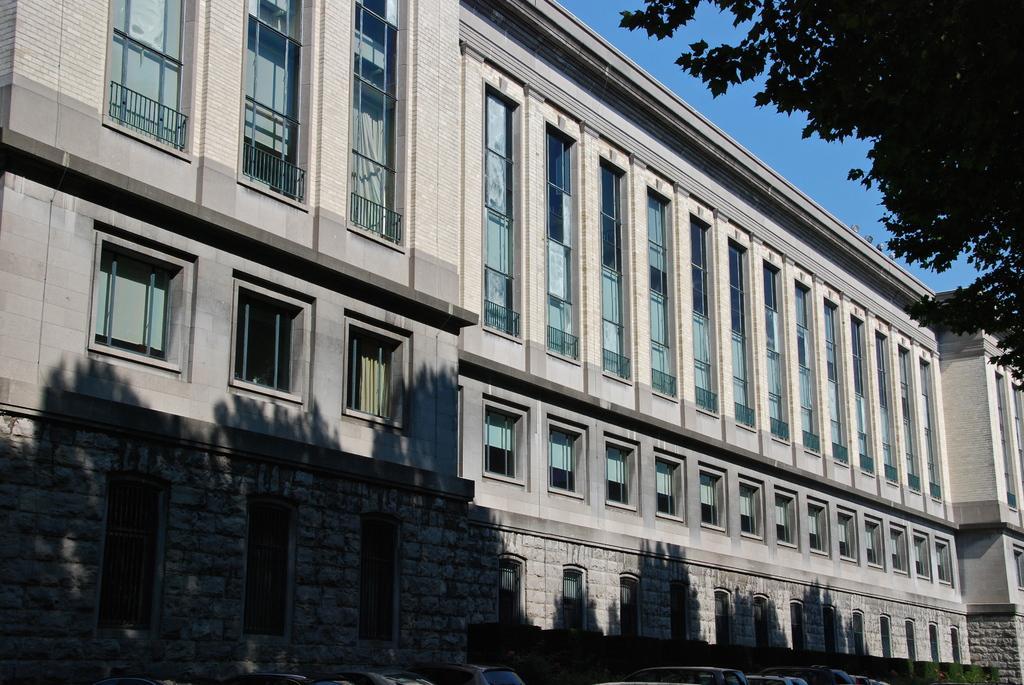In one or two sentences, can you explain what this image depicts? In this image in the center there is one building, and on the top of the right corner there is one tree and sky. 